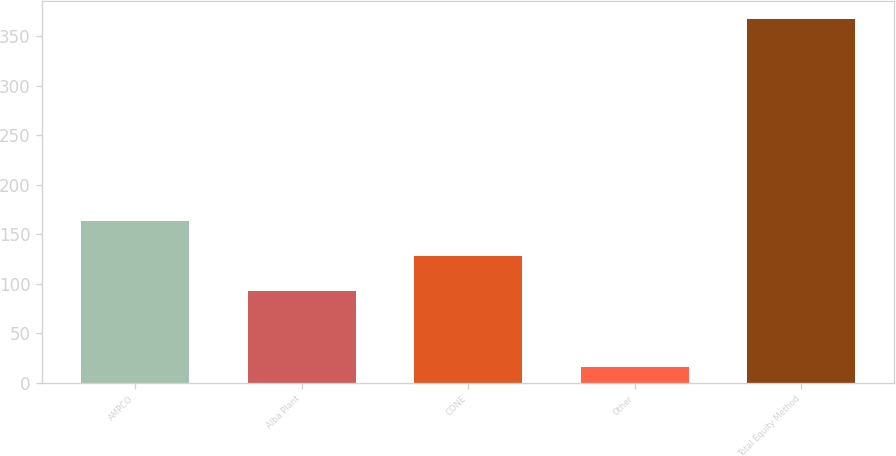<chart> <loc_0><loc_0><loc_500><loc_500><bar_chart><fcel>AMPCO<fcel>Alba Plant<fcel>CONE<fcel>Other<fcel>Total Equity Method<nl><fcel>163.2<fcel>93<fcel>128.1<fcel>16<fcel>367<nl></chart> 